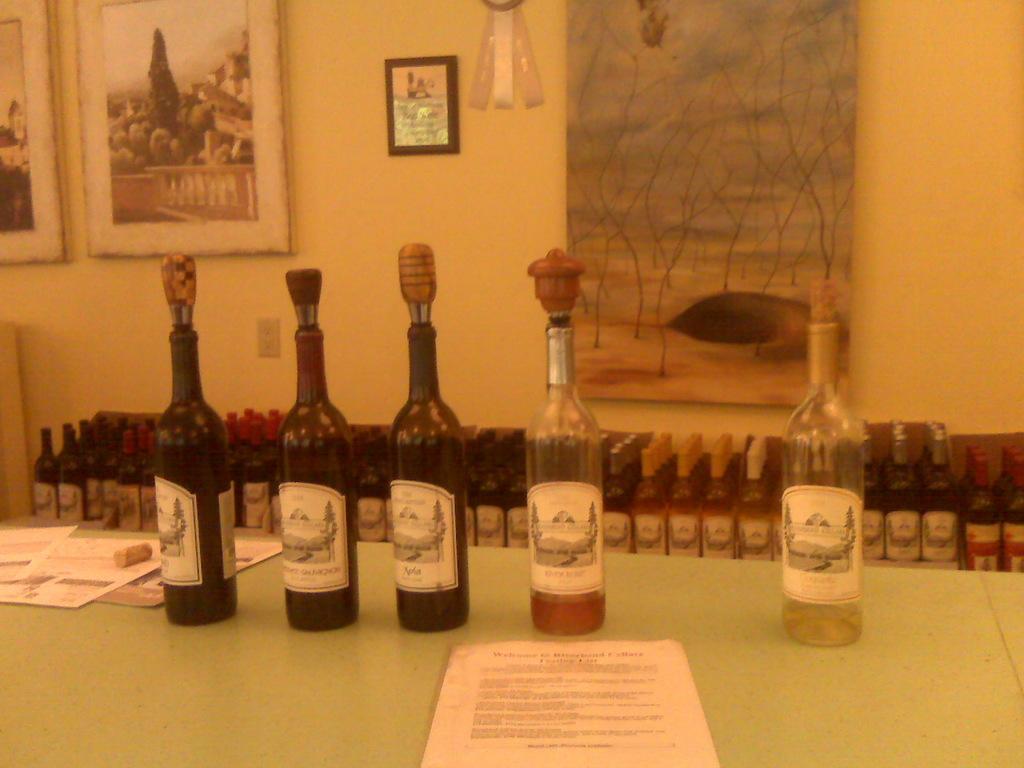What is in the bottles?
Your answer should be very brief. Wine. 